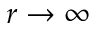<formula> <loc_0><loc_0><loc_500><loc_500>r \rightarrow \infty</formula> 